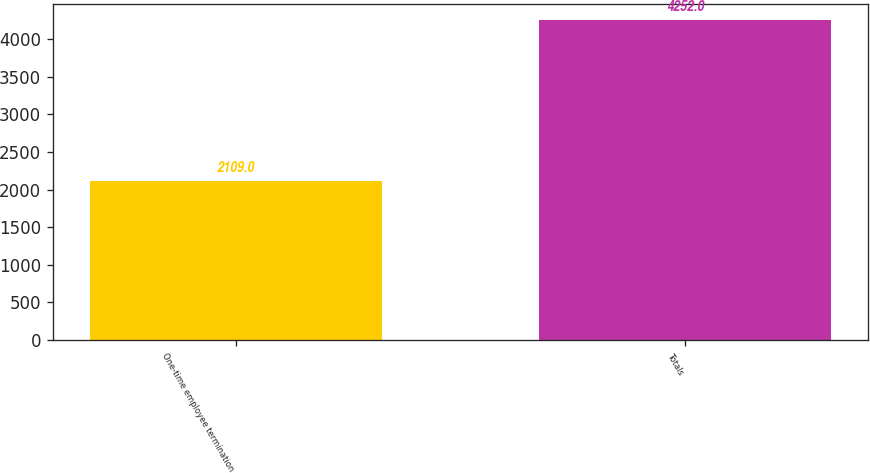Convert chart. <chart><loc_0><loc_0><loc_500><loc_500><bar_chart><fcel>One-time employee termination<fcel>Totals<nl><fcel>2109<fcel>4252<nl></chart> 